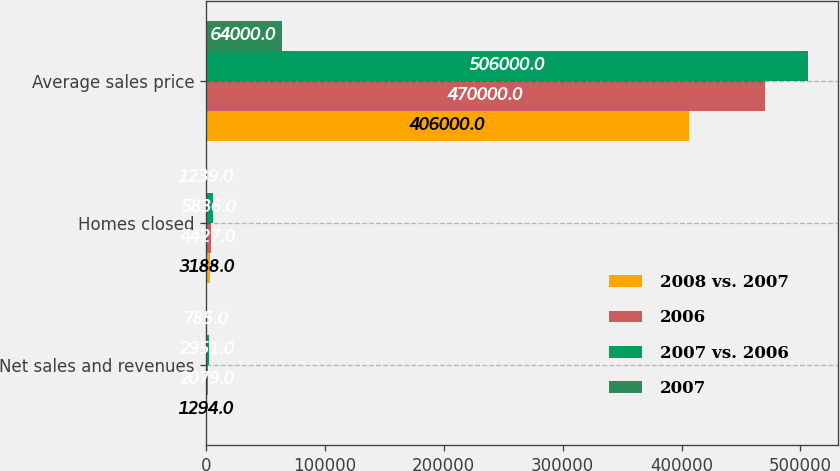Convert chart to OTSL. <chart><loc_0><loc_0><loc_500><loc_500><stacked_bar_chart><ecel><fcel>Net sales and revenues<fcel>Homes closed<fcel>Average sales price<nl><fcel>2008 vs. 2007<fcel>1294<fcel>3188<fcel>406000<nl><fcel>2006<fcel>2079<fcel>4427<fcel>470000<nl><fcel>2007 vs. 2006<fcel>2951<fcel>5836<fcel>506000<nl><fcel>2007<fcel>785<fcel>1239<fcel>64000<nl></chart> 